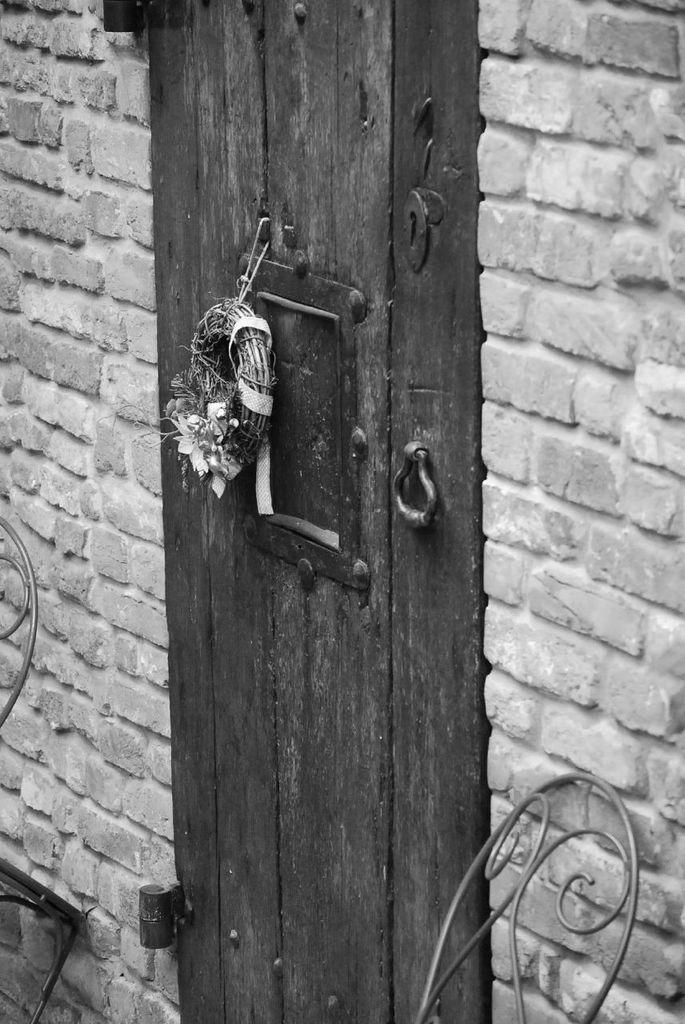What is a prominent feature in the image? There is a door in the image. What is the door attached to? The door is part of a brick wall. Has the door been modified in any way? Yes, something has been changed on the door. Can you see any grapes growing on the door in the image? No, there are no grapes present on the door in the image. What type of support is the door providing in the image? The door is not providing any support in the image; it is a door that can be opened and closed. 